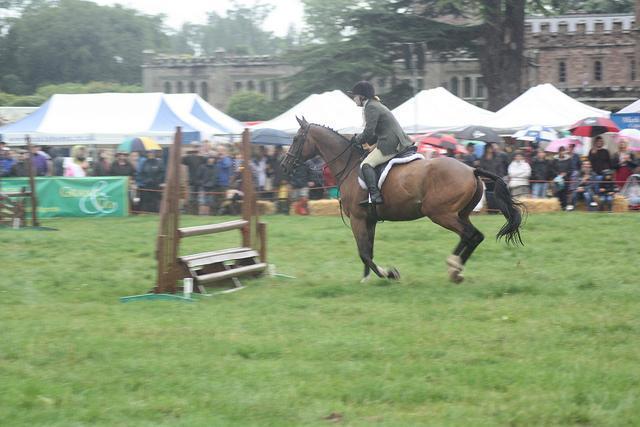How many tents are visible?
Give a very brief answer. 5. How many people are in the photo?
Give a very brief answer. 2. How many umbrellas are in the picture?
Give a very brief answer. 2. How many chairs are there?
Give a very brief answer. 0. 